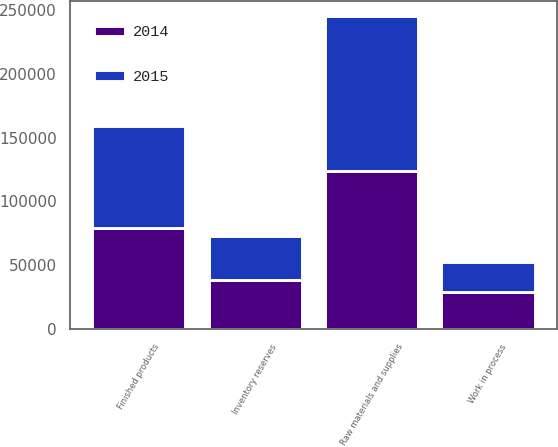Convert chart. <chart><loc_0><loc_0><loc_500><loc_500><stacked_bar_chart><ecel><fcel>Raw materials and supplies<fcel>Work in process<fcel>Finished products<fcel>Inventory reserves<nl><fcel>2015<fcel>120811<fcel>22979<fcel>80118<fcel>34040<nl><fcel>2014<fcel>124103<fcel>29358<fcel>79184<fcel>38879<nl></chart> 